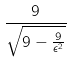<formula> <loc_0><loc_0><loc_500><loc_500>\frac { 9 } { \sqrt { 9 - \frac { 9 } { \epsilon ^ { 2 } } } }</formula> 